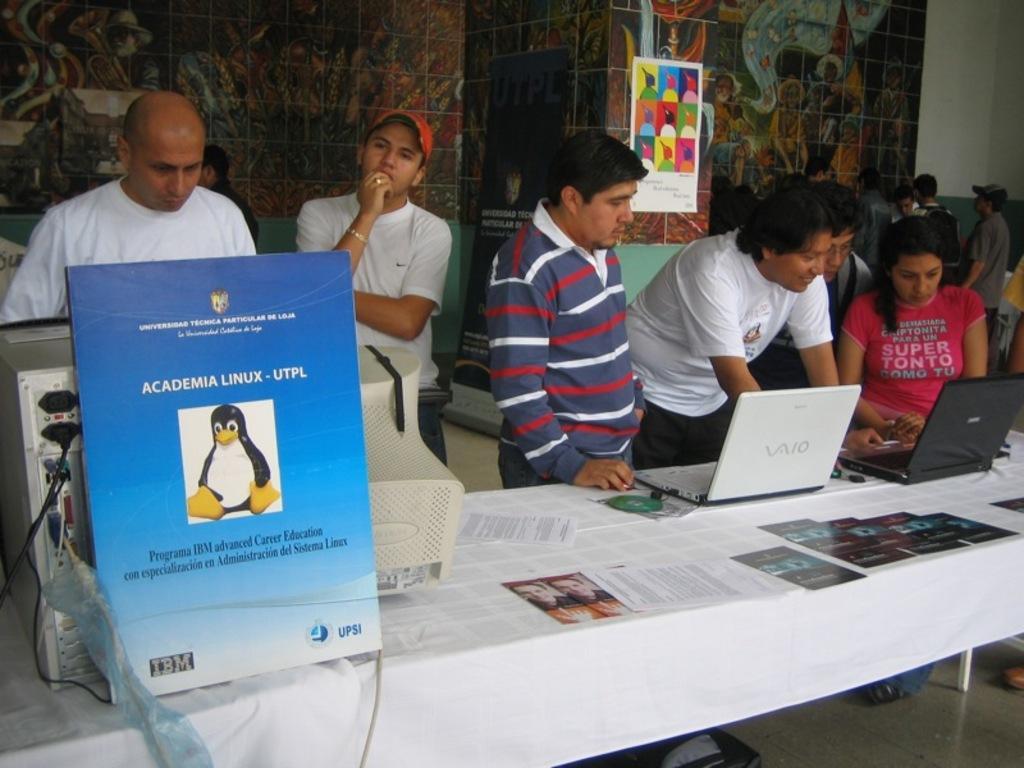Could you give a brief overview of what you see in this image? In this image, at the bottom there is a table on that there are papers, posters, computer, cpu, board, laptops, cd's, cloth. On the right there is a man, he wears a t shirt. In the middle there are many people, posters, banners, wall. 